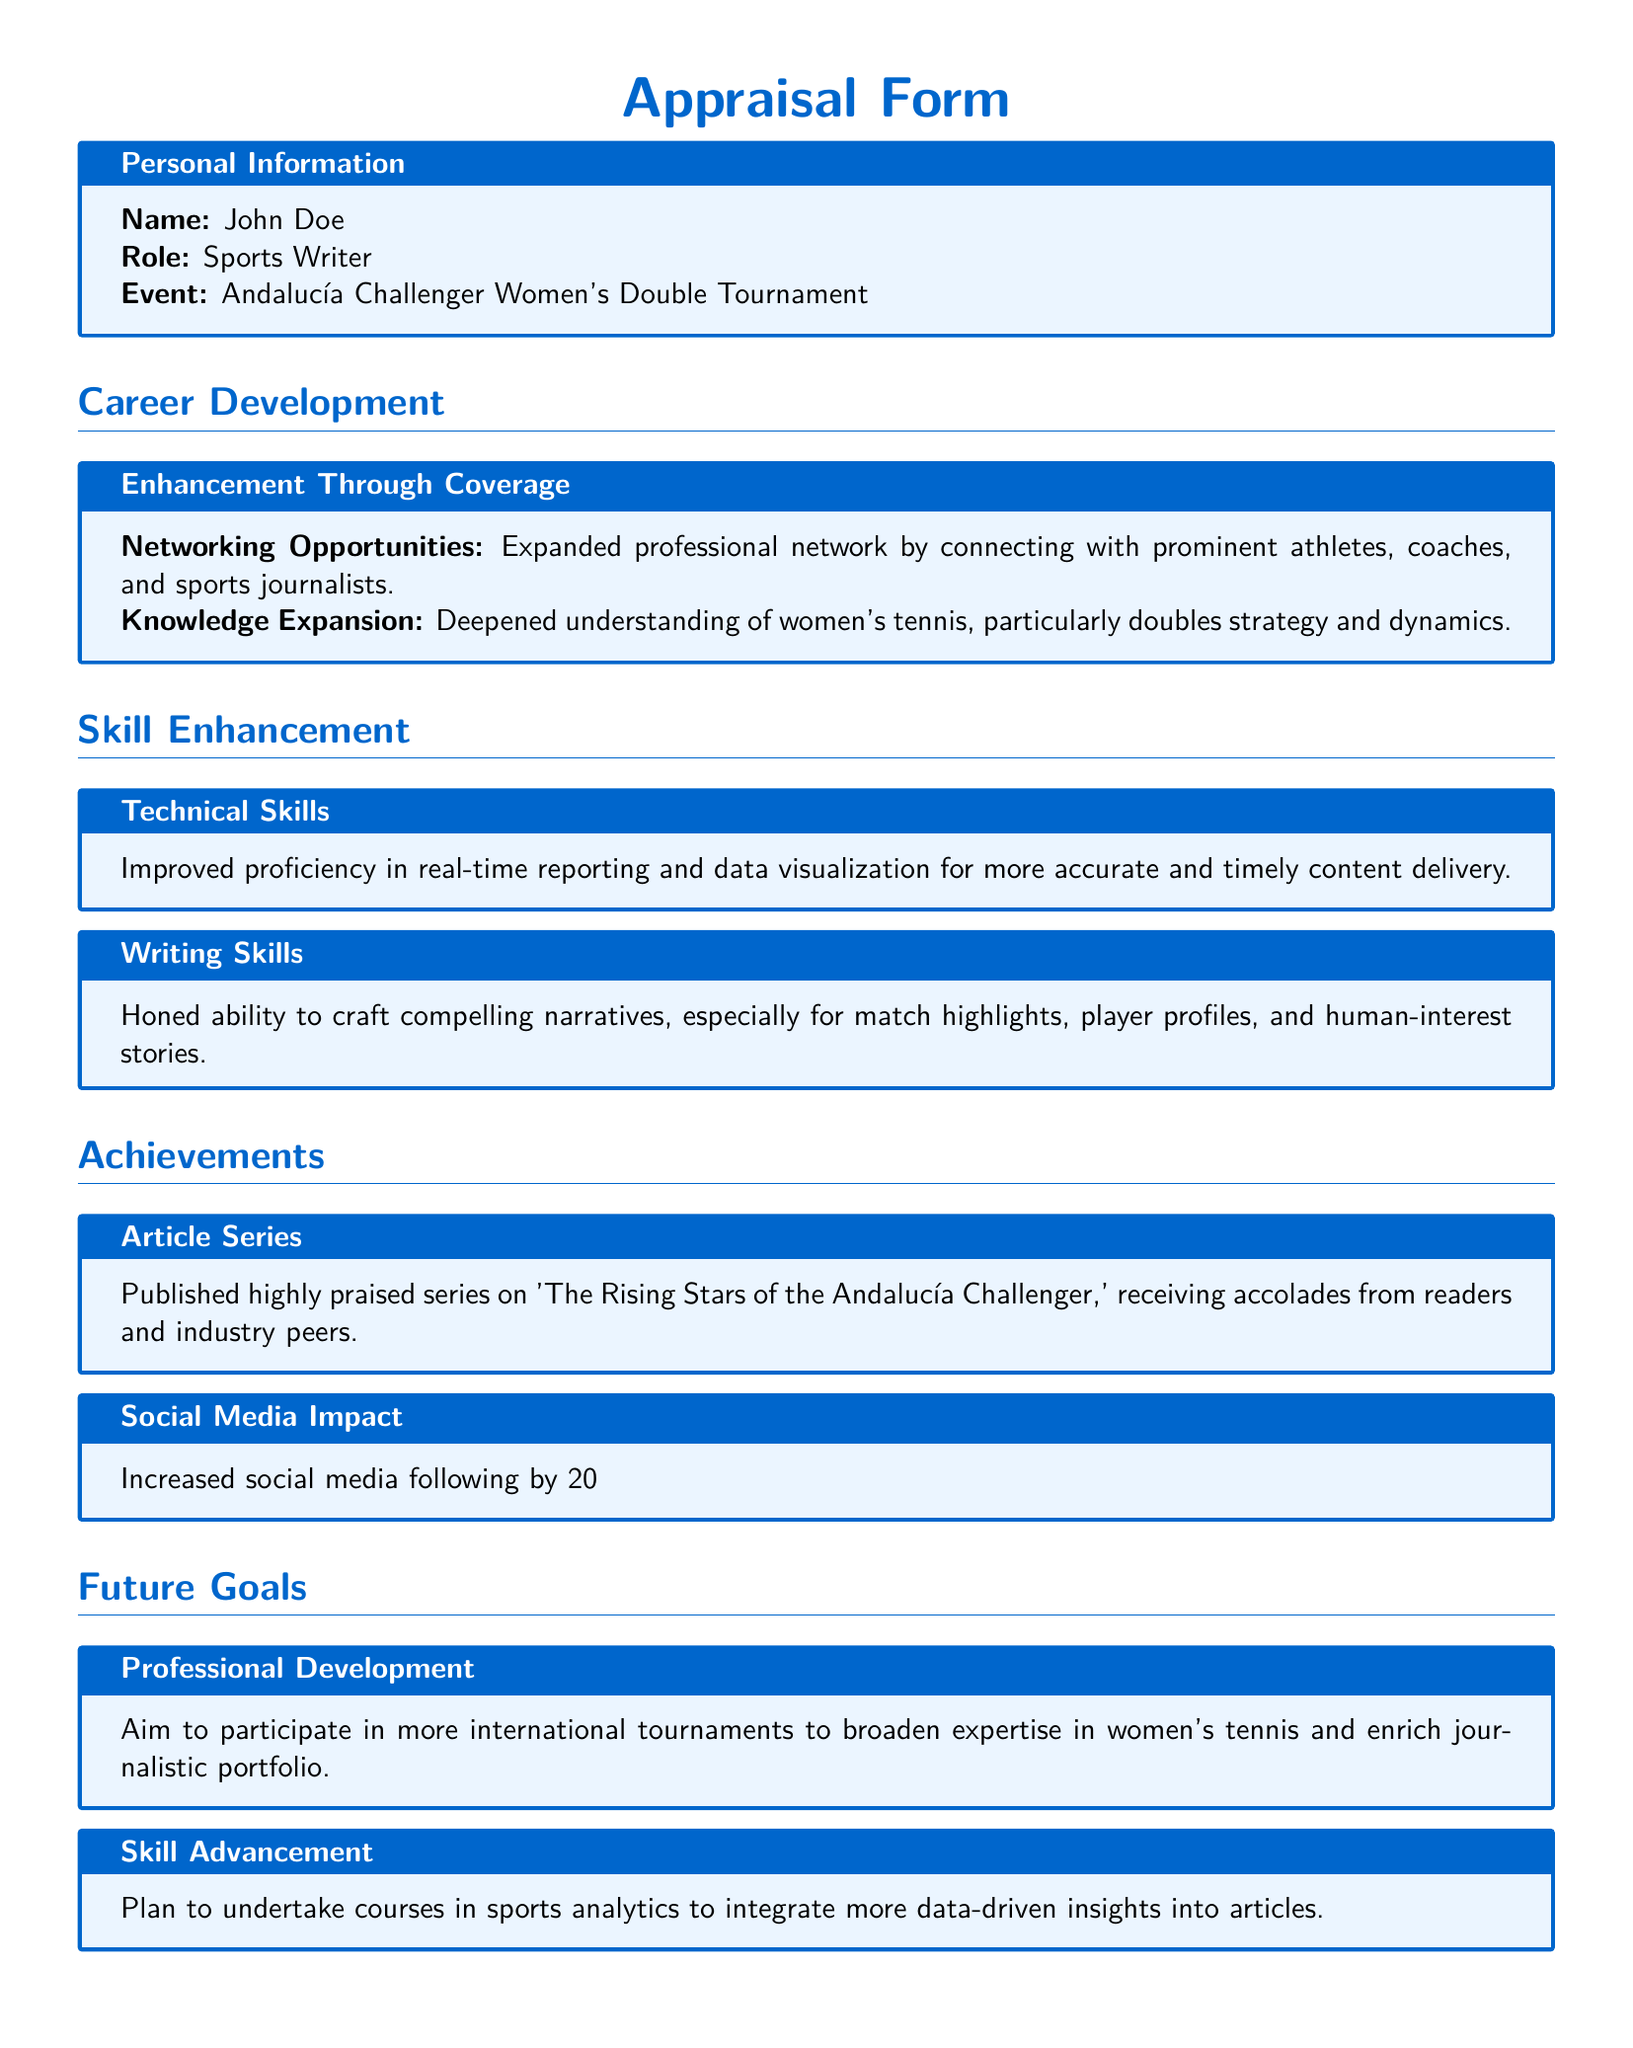what is the name of the individual filling out the form? The name of the individual is mentioned in the personal information section of the document.
Answer: John Doe what role does the individual hold? The role is specified in the personal information section of the document.
Answer: Sports Writer what event does this appraisal form pertain to? The event is listed in the personal information section of the document.
Answer: Andalucía Challenger Women's Double Tournament what improvement in skills is mentioned under technical skills? The specific skill improvement is detailed in the skill enhancement section.
Answer: Proficiency in real-time reporting and data visualization by what percentage did the individual's social media following increase? This information is stated in the achievements section regarding social media impact.
Answer: 20% what is one of the future goals of the individual? The future goals are outlined in a specific section of the document, focusing on professional development.
Answer: Participate in more international tournaments what series did the individual publish related to the tournament? The achievements section notes the title of the article series published by the individual.
Answer: The Rising Stars of the Andalucía Challenger how has the individual's understanding of women’s tennis changed? This is summarized in the career development section regarding knowledge expansion.
Answer: Deepened understanding of women's tennis what type of courses does the individual plan to undertake for skill advancement? The skill advancement plans are specified in the future goals section of the document.
Answer: Courses in sports analytics 